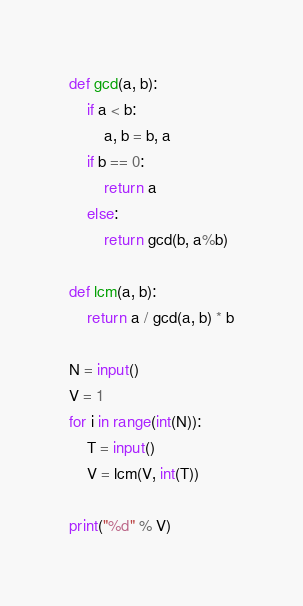Convert code to text. <code><loc_0><loc_0><loc_500><loc_500><_Python_>def gcd(a, b):
    if a < b:
        a, b = b, a
    if b == 0:
        return a
    else:
        return gcd(b, a%b)

def lcm(a, b):
    return a / gcd(a, b) * b

N = input()
V = 1
for i in range(int(N)):
    T = input()
    V = lcm(V, int(T))

print("%d" % V)</code> 